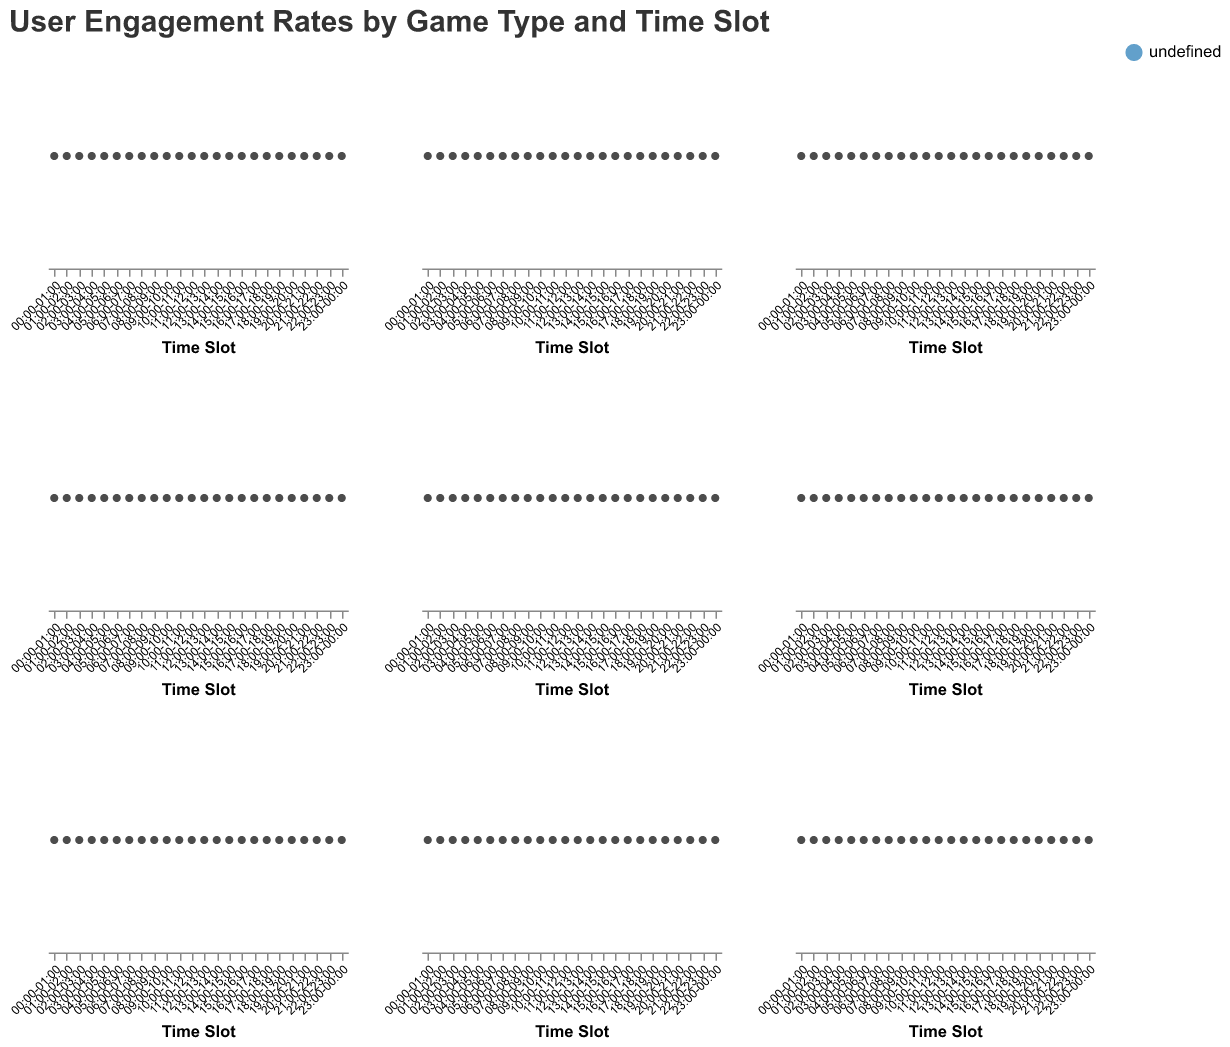How many different types of games are displayed in the figure? The figure includes multiple subplots for different game types. Each subplot header indicates the types of games being displayed. By counting these headers, we can see there are six different game types.
Answer: Six Which game type has the highest user engagement rate at 23:00-00:00? To determine the highest user engagement rate, look at the figures for the time slot 23:00-00:00 across all game types. The highest value in this time slot is for "Slots Games" with an engagement rate of 100.
Answer: Slots Games What is the overall trend in user engagement rate for Blackjack from 00:00 to 23:00? Observing the area plot for Blackjack, we can see a gradual increase in engagement rates, indicating an upward trend throughout the day.
Answer: Upward trend During which time slot does Sports Betting show the sharpest increase in user engagement rate? To find the sharpest increase, refer to the Sports Betting subplot and compare the increments between consecutive time slots. The sharpest increase is between 16:00-17:00 and 17:00-18:00, where the rate goes from 45 to 50.
Answer: 17:00-18:00 What is the difference in user engagement rates for Poker between 02:00-03:00 and 04:00-05:00? Referring to the data points in the Poker subplot, the engagement rates at 02:00-03:00 and 04:00-05:00 are 3 and 2, respectively. The difference is 3 - 2 = 1.
Answer: 1 Compare the engagement rates at 10:00-11:00 for Slots Games and Baccarat. Which has a higher rate and by how much? From the plots, the engagement rates at 10:00-11:00 are 30 for Slots Games and 17 for Baccarat. Slots Games has a higher rate by 30 - 17 = 13.
Answer: Slots Games by 13 Which game type shows the least engagement at 04:00-05:00? From the plots for different game types, at 04:00-05:00, the game type with the least engagement is Poker with an engagement rate of 2.
Answer: Poker What's the average engagement rate for Roulette between 15:00-16:00 and 18:00-19:00? In the Roulette subplot, the engagement rates are 27 for 15:00-16:00 and 37 for 18:00-19:00. The average is (27 + 37) / 2 = 32.
Answer: 32 Which two game types have the most similar trends in engagement rates throughout the day? By visually comparing the trends across the subplots, Slots Games and Sports Betting have engagement rates that increase steadily throughout the day and peak towards midnight, indicating a similar trend.
Answer: Slots Games and Sports Betting In which time slot does Baccarat's engagement rate equal that of Roulette? By comparing the plots for Baccarat and Roulette, their engagement rates are equal at 50 during the 23:00-00:00 time slot.
Answer: 23:00-00:00 